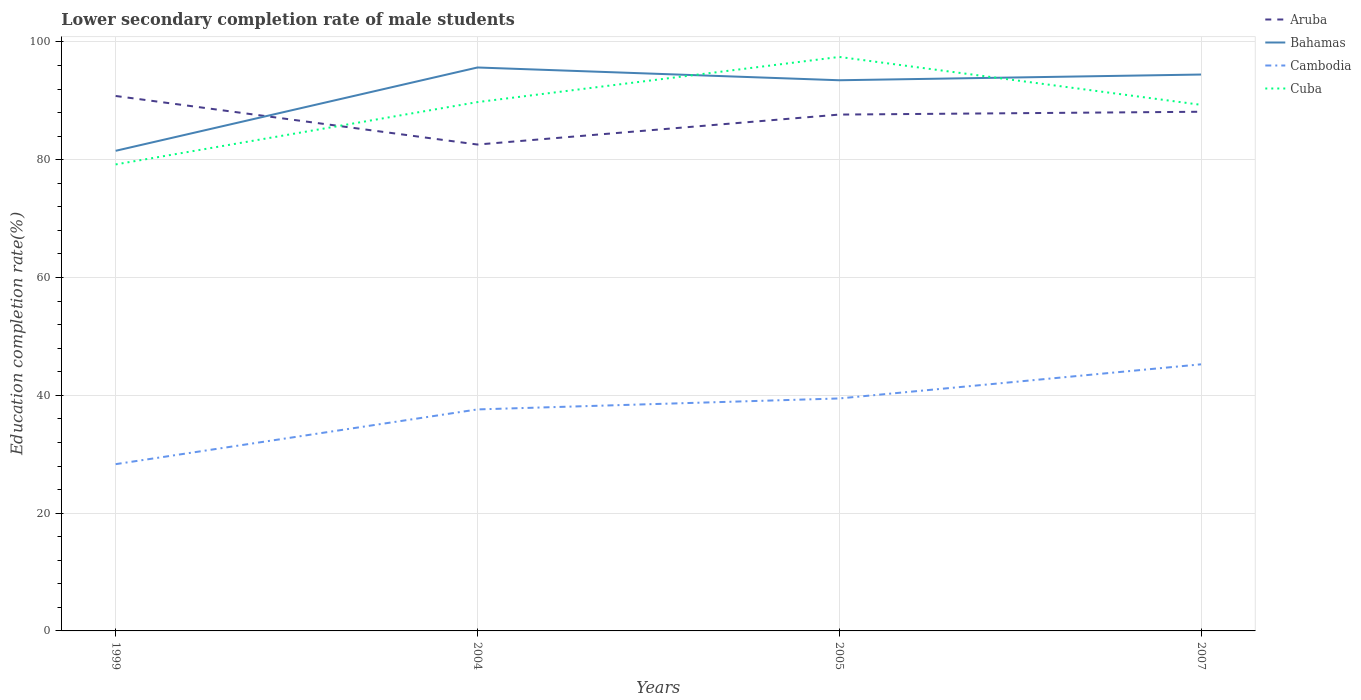How many different coloured lines are there?
Your response must be concise. 4. Is the number of lines equal to the number of legend labels?
Make the answer very short. Yes. Across all years, what is the maximum lower secondary completion rate of male students in Bahamas?
Offer a terse response. 81.51. What is the total lower secondary completion rate of male students in Cambodia in the graph?
Your response must be concise. -16.95. What is the difference between the highest and the second highest lower secondary completion rate of male students in Bahamas?
Make the answer very short. 14.15. How many years are there in the graph?
Your response must be concise. 4. What is the difference between two consecutive major ticks on the Y-axis?
Provide a succinct answer. 20. Are the values on the major ticks of Y-axis written in scientific E-notation?
Offer a terse response. No. Does the graph contain grids?
Make the answer very short. Yes. Where does the legend appear in the graph?
Offer a very short reply. Top right. How many legend labels are there?
Your answer should be very brief. 4. How are the legend labels stacked?
Your answer should be very brief. Vertical. What is the title of the graph?
Provide a short and direct response. Lower secondary completion rate of male students. What is the label or title of the X-axis?
Provide a short and direct response. Years. What is the label or title of the Y-axis?
Keep it short and to the point. Education completion rate(%). What is the Education completion rate(%) of Aruba in 1999?
Keep it short and to the point. 90.82. What is the Education completion rate(%) in Bahamas in 1999?
Your response must be concise. 81.51. What is the Education completion rate(%) of Cambodia in 1999?
Keep it short and to the point. 28.31. What is the Education completion rate(%) in Cuba in 1999?
Ensure brevity in your answer.  79.2. What is the Education completion rate(%) in Aruba in 2004?
Your answer should be compact. 82.58. What is the Education completion rate(%) in Bahamas in 2004?
Your answer should be compact. 95.66. What is the Education completion rate(%) in Cambodia in 2004?
Ensure brevity in your answer.  37.61. What is the Education completion rate(%) of Cuba in 2004?
Provide a succinct answer. 89.79. What is the Education completion rate(%) of Aruba in 2005?
Give a very brief answer. 87.67. What is the Education completion rate(%) of Bahamas in 2005?
Provide a short and direct response. 93.5. What is the Education completion rate(%) in Cambodia in 2005?
Offer a terse response. 39.47. What is the Education completion rate(%) of Cuba in 2005?
Ensure brevity in your answer.  97.45. What is the Education completion rate(%) in Aruba in 2007?
Your answer should be very brief. 88.15. What is the Education completion rate(%) in Bahamas in 2007?
Your answer should be very brief. 94.47. What is the Education completion rate(%) in Cambodia in 2007?
Offer a terse response. 45.26. What is the Education completion rate(%) of Cuba in 2007?
Your answer should be very brief. 89.32. Across all years, what is the maximum Education completion rate(%) in Aruba?
Your answer should be compact. 90.82. Across all years, what is the maximum Education completion rate(%) of Bahamas?
Give a very brief answer. 95.66. Across all years, what is the maximum Education completion rate(%) of Cambodia?
Your answer should be very brief. 45.26. Across all years, what is the maximum Education completion rate(%) in Cuba?
Your answer should be compact. 97.45. Across all years, what is the minimum Education completion rate(%) of Aruba?
Your response must be concise. 82.58. Across all years, what is the minimum Education completion rate(%) in Bahamas?
Your answer should be very brief. 81.51. Across all years, what is the minimum Education completion rate(%) in Cambodia?
Make the answer very short. 28.31. Across all years, what is the minimum Education completion rate(%) in Cuba?
Offer a terse response. 79.2. What is the total Education completion rate(%) in Aruba in the graph?
Provide a short and direct response. 349.22. What is the total Education completion rate(%) of Bahamas in the graph?
Your answer should be very brief. 365.14. What is the total Education completion rate(%) of Cambodia in the graph?
Ensure brevity in your answer.  150.65. What is the total Education completion rate(%) in Cuba in the graph?
Make the answer very short. 355.77. What is the difference between the Education completion rate(%) of Aruba in 1999 and that in 2004?
Your response must be concise. 8.25. What is the difference between the Education completion rate(%) of Bahamas in 1999 and that in 2004?
Your response must be concise. -14.15. What is the difference between the Education completion rate(%) in Cambodia in 1999 and that in 2004?
Give a very brief answer. -9.29. What is the difference between the Education completion rate(%) in Cuba in 1999 and that in 2004?
Your response must be concise. -10.58. What is the difference between the Education completion rate(%) of Aruba in 1999 and that in 2005?
Offer a very short reply. 3.16. What is the difference between the Education completion rate(%) in Bahamas in 1999 and that in 2005?
Provide a short and direct response. -11.98. What is the difference between the Education completion rate(%) of Cambodia in 1999 and that in 2005?
Your answer should be compact. -11.16. What is the difference between the Education completion rate(%) of Cuba in 1999 and that in 2005?
Your response must be concise. -18.25. What is the difference between the Education completion rate(%) in Aruba in 1999 and that in 2007?
Your response must be concise. 2.68. What is the difference between the Education completion rate(%) in Bahamas in 1999 and that in 2007?
Give a very brief answer. -12.95. What is the difference between the Education completion rate(%) of Cambodia in 1999 and that in 2007?
Ensure brevity in your answer.  -16.95. What is the difference between the Education completion rate(%) of Cuba in 1999 and that in 2007?
Your response must be concise. -10.12. What is the difference between the Education completion rate(%) of Aruba in 2004 and that in 2005?
Your answer should be very brief. -5.09. What is the difference between the Education completion rate(%) of Bahamas in 2004 and that in 2005?
Your answer should be very brief. 2.17. What is the difference between the Education completion rate(%) of Cambodia in 2004 and that in 2005?
Offer a terse response. -1.86. What is the difference between the Education completion rate(%) in Cuba in 2004 and that in 2005?
Provide a succinct answer. -7.67. What is the difference between the Education completion rate(%) in Aruba in 2004 and that in 2007?
Your response must be concise. -5.57. What is the difference between the Education completion rate(%) in Bahamas in 2004 and that in 2007?
Keep it short and to the point. 1.19. What is the difference between the Education completion rate(%) in Cambodia in 2004 and that in 2007?
Offer a terse response. -7.65. What is the difference between the Education completion rate(%) in Cuba in 2004 and that in 2007?
Provide a succinct answer. 0.46. What is the difference between the Education completion rate(%) of Aruba in 2005 and that in 2007?
Provide a short and direct response. -0.48. What is the difference between the Education completion rate(%) of Bahamas in 2005 and that in 2007?
Your response must be concise. -0.97. What is the difference between the Education completion rate(%) in Cambodia in 2005 and that in 2007?
Your answer should be compact. -5.79. What is the difference between the Education completion rate(%) in Cuba in 2005 and that in 2007?
Make the answer very short. 8.13. What is the difference between the Education completion rate(%) in Aruba in 1999 and the Education completion rate(%) in Bahamas in 2004?
Give a very brief answer. -4.84. What is the difference between the Education completion rate(%) of Aruba in 1999 and the Education completion rate(%) of Cambodia in 2004?
Offer a very short reply. 53.22. What is the difference between the Education completion rate(%) in Aruba in 1999 and the Education completion rate(%) in Cuba in 2004?
Offer a terse response. 1.04. What is the difference between the Education completion rate(%) of Bahamas in 1999 and the Education completion rate(%) of Cambodia in 2004?
Keep it short and to the point. 43.91. What is the difference between the Education completion rate(%) in Bahamas in 1999 and the Education completion rate(%) in Cuba in 2004?
Offer a terse response. -8.27. What is the difference between the Education completion rate(%) in Cambodia in 1999 and the Education completion rate(%) in Cuba in 2004?
Your answer should be compact. -61.47. What is the difference between the Education completion rate(%) in Aruba in 1999 and the Education completion rate(%) in Bahamas in 2005?
Your response must be concise. -2.67. What is the difference between the Education completion rate(%) in Aruba in 1999 and the Education completion rate(%) in Cambodia in 2005?
Make the answer very short. 51.35. What is the difference between the Education completion rate(%) of Aruba in 1999 and the Education completion rate(%) of Cuba in 2005?
Your answer should be compact. -6.63. What is the difference between the Education completion rate(%) in Bahamas in 1999 and the Education completion rate(%) in Cambodia in 2005?
Ensure brevity in your answer.  42.05. What is the difference between the Education completion rate(%) in Bahamas in 1999 and the Education completion rate(%) in Cuba in 2005?
Provide a succinct answer. -15.94. What is the difference between the Education completion rate(%) of Cambodia in 1999 and the Education completion rate(%) of Cuba in 2005?
Your answer should be compact. -69.14. What is the difference between the Education completion rate(%) of Aruba in 1999 and the Education completion rate(%) of Bahamas in 2007?
Your response must be concise. -3.64. What is the difference between the Education completion rate(%) of Aruba in 1999 and the Education completion rate(%) of Cambodia in 2007?
Ensure brevity in your answer.  45.56. What is the difference between the Education completion rate(%) of Aruba in 1999 and the Education completion rate(%) of Cuba in 2007?
Ensure brevity in your answer.  1.5. What is the difference between the Education completion rate(%) of Bahamas in 1999 and the Education completion rate(%) of Cambodia in 2007?
Your response must be concise. 36.25. What is the difference between the Education completion rate(%) in Bahamas in 1999 and the Education completion rate(%) in Cuba in 2007?
Provide a succinct answer. -7.81. What is the difference between the Education completion rate(%) in Cambodia in 1999 and the Education completion rate(%) in Cuba in 2007?
Your answer should be compact. -61.01. What is the difference between the Education completion rate(%) in Aruba in 2004 and the Education completion rate(%) in Bahamas in 2005?
Offer a very short reply. -10.92. What is the difference between the Education completion rate(%) in Aruba in 2004 and the Education completion rate(%) in Cambodia in 2005?
Provide a short and direct response. 43.11. What is the difference between the Education completion rate(%) of Aruba in 2004 and the Education completion rate(%) of Cuba in 2005?
Give a very brief answer. -14.87. What is the difference between the Education completion rate(%) of Bahamas in 2004 and the Education completion rate(%) of Cambodia in 2005?
Your answer should be very brief. 56.19. What is the difference between the Education completion rate(%) in Bahamas in 2004 and the Education completion rate(%) in Cuba in 2005?
Your response must be concise. -1.79. What is the difference between the Education completion rate(%) in Cambodia in 2004 and the Education completion rate(%) in Cuba in 2005?
Provide a short and direct response. -59.85. What is the difference between the Education completion rate(%) of Aruba in 2004 and the Education completion rate(%) of Bahamas in 2007?
Provide a short and direct response. -11.89. What is the difference between the Education completion rate(%) of Aruba in 2004 and the Education completion rate(%) of Cambodia in 2007?
Offer a terse response. 37.32. What is the difference between the Education completion rate(%) of Aruba in 2004 and the Education completion rate(%) of Cuba in 2007?
Offer a very short reply. -6.74. What is the difference between the Education completion rate(%) in Bahamas in 2004 and the Education completion rate(%) in Cambodia in 2007?
Your response must be concise. 50.4. What is the difference between the Education completion rate(%) of Bahamas in 2004 and the Education completion rate(%) of Cuba in 2007?
Your answer should be compact. 6.34. What is the difference between the Education completion rate(%) of Cambodia in 2004 and the Education completion rate(%) of Cuba in 2007?
Ensure brevity in your answer.  -51.72. What is the difference between the Education completion rate(%) in Aruba in 2005 and the Education completion rate(%) in Bahamas in 2007?
Your answer should be very brief. -6.8. What is the difference between the Education completion rate(%) in Aruba in 2005 and the Education completion rate(%) in Cambodia in 2007?
Provide a succinct answer. 42.4. What is the difference between the Education completion rate(%) in Aruba in 2005 and the Education completion rate(%) in Cuba in 2007?
Your response must be concise. -1.66. What is the difference between the Education completion rate(%) of Bahamas in 2005 and the Education completion rate(%) of Cambodia in 2007?
Your answer should be very brief. 48.23. What is the difference between the Education completion rate(%) in Bahamas in 2005 and the Education completion rate(%) in Cuba in 2007?
Provide a succinct answer. 4.17. What is the difference between the Education completion rate(%) in Cambodia in 2005 and the Education completion rate(%) in Cuba in 2007?
Make the answer very short. -49.85. What is the average Education completion rate(%) of Aruba per year?
Provide a succinct answer. 87.3. What is the average Education completion rate(%) of Bahamas per year?
Provide a short and direct response. 91.28. What is the average Education completion rate(%) of Cambodia per year?
Offer a very short reply. 37.66. What is the average Education completion rate(%) of Cuba per year?
Your answer should be compact. 88.94. In the year 1999, what is the difference between the Education completion rate(%) of Aruba and Education completion rate(%) of Bahamas?
Offer a very short reply. 9.31. In the year 1999, what is the difference between the Education completion rate(%) in Aruba and Education completion rate(%) in Cambodia?
Your response must be concise. 62.51. In the year 1999, what is the difference between the Education completion rate(%) of Aruba and Education completion rate(%) of Cuba?
Keep it short and to the point. 11.62. In the year 1999, what is the difference between the Education completion rate(%) of Bahamas and Education completion rate(%) of Cambodia?
Ensure brevity in your answer.  53.2. In the year 1999, what is the difference between the Education completion rate(%) of Bahamas and Education completion rate(%) of Cuba?
Offer a very short reply. 2.31. In the year 1999, what is the difference between the Education completion rate(%) in Cambodia and Education completion rate(%) in Cuba?
Your response must be concise. -50.89. In the year 2004, what is the difference between the Education completion rate(%) of Aruba and Education completion rate(%) of Bahamas?
Your answer should be very brief. -13.08. In the year 2004, what is the difference between the Education completion rate(%) in Aruba and Education completion rate(%) in Cambodia?
Provide a succinct answer. 44.97. In the year 2004, what is the difference between the Education completion rate(%) of Aruba and Education completion rate(%) of Cuba?
Your answer should be very brief. -7.21. In the year 2004, what is the difference between the Education completion rate(%) in Bahamas and Education completion rate(%) in Cambodia?
Give a very brief answer. 58.05. In the year 2004, what is the difference between the Education completion rate(%) in Bahamas and Education completion rate(%) in Cuba?
Provide a short and direct response. 5.87. In the year 2004, what is the difference between the Education completion rate(%) of Cambodia and Education completion rate(%) of Cuba?
Your response must be concise. -52.18. In the year 2005, what is the difference between the Education completion rate(%) of Aruba and Education completion rate(%) of Bahamas?
Your answer should be compact. -5.83. In the year 2005, what is the difference between the Education completion rate(%) in Aruba and Education completion rate(%) in Cambodia?
Make the answer very short. 48.2. In the year 2005, what is the difference between the Education completion rate(%) in Aruba and Education completion rate(%) in Cuba?
Your response must be concise. -9.79. In the year 2005, what is the difference between the Education completion rate(%) of Bahamas and Education completion rate(%) of Cambodia?
Provide a short and direct response. 54.03. In the year 2005, what is the difference between the Education completion rate(%) in Bahamas and Education completion rate(%) in Cuba?
Your response must be concise. -3.96. In the year 2005, what is the difference between the Education completion rate(%) in Cambodia and Education completion rate(%) in Cuba?
Give a very brief answer. -57.98. In the year 2007, what is the difference between the Education completion rate(%) in Aruba and Education completion rate(%) in Bahamas?
Keep it short and to the point. -6.32. In the year 2007, what is the difference between the Education completion rate(%) of Aruba and Education completion rate(%) of Cambodia?
Offer a very short reply. 42.88. In the year 2007, what is the difference between the Education completion rate(%) of Aruba and Education completion rate(%) of Cuba?
Ensure brevity in your answer.  -1.18. In the year 2007, what is the difference between the Education completion rate(%) of Bahamas and Education completion rate(%) of Cambodia?
Offer a very short reply. 49.2. In the year 2007, what is the difference between the Education completion rate(%) in Bahamas and Education completion rate(%) in Cuba?
Your response must be concise. 5.14. In the year 2007, what is the difference between the Education completion rate(%) of Cambodia and Education completion rate(%) of Cuba?
Provide a succinct answer. -44.06. What is the ratio of the Education completion rate(%) in Aruba in 1999 to that in 2004?
Give a very brief answer. 1.1. What is the ratio of the Education completion rate(%) in Bahamas in 1999 to that in 2004?
Give a very brief answer. 0.85. What is the ratio of the Education completion rate(%) of Cambodia in 1999 to that in 2004?
Ensure brevity in your answer.  0.75. What is the ratio of the Education completion rate(%) in Cuba in 1999 to that in 2004?
Your response must be concise. 0.88. What is the ratio of the Education completion rate(%) in Aruba in 1999 to that in 2005?
Offer a terse response. 1.04. What is the ratio of the Education completion rate(%) of Bahamas in 1999 to that in 2005?
Keep it short and to the point. 0.87. What is the ratio of the Education completion rate(%) of Cambodia in 1999 to that in 2005?
Your answer should be compact. 0.72. What is the ratio of the Education completion rate(%) in Cuba in 1999 to that in 2005?
Your answer should be very brief. 0.81. What is the ratio of the Education completion rate(%) of Aruba in 1999 to that in 2007?
Make the answer very short. 1.03. What is the ratio of the Education completion rate(%) in Bahamas in 1999 to that in 2007?
Keep it short and to the point. 0.86. What is the ratio of the Education completion rate(%) of Cambodia in 1999 to that in 2007?
Give a very brief answer. 0.63. What is the ratio of the Education completion rate(%) of Cuba in 1999 to that in 2007?
Provide a succinct answer. 0.89. What is the ratio of the Education completion rate(%) in Aruba in 2004 to that in 2005?
Your response must be concise. 0.94. What is the ratio of the Education completion rate(%) in Bahamas in 2004 to that in 2005?
Your answer should be very brief. 1.02. What is the ratio of the Education completion rate(%) in Cambodia in 2004 to that in 2005?
Offer a terse response. 0.95. What is the ratio of the Education completion rate(%) in Cuba in 2004 to that in 2005?
Keep it short and to the point. 0.92. What is the ratio of the Education completion rate(%) in Aruba in 2004 to that in 2007?
Keep it short and to the point. 0.94. What is the ratio of the Education completion rate(%) of Bahamas in 2004 to that in 2007?
Make the answer very short. 1.01. What is the ratio of the Education completion rate(%) of Cambodia in 2004 to that in 2007?
Offer a terse response. 0.83. What is the ratio of the Education completion rate(%) in Bahamas in 2005 to that in 2007?
Provide a short and direct response. 0.99. What is the ratio of the Education completion rate(%) in Cambodia in 2005 to that in 2007?
Offer a very short reply. 0.87. What is the ratio of the Education completion rate(%) in Cuba in 2005 to that in 2007?
Give a very brief answer. 1.09. What is the difference between the highest and the second highest Education completion rate(%) of Aruba?
Provide a succinct answer. 2.68. What is the difference between the highest and the second highest Education completion rate(%) in Bahamas?
Provide a short and direct response. 1.19. What is the difference between the highest and the second highest Education completion rate(%) of Cambodia?
Offer a terse response. 5.79. What is the difference between the highest and the second highest Education completion rate(%) of Cuba?
Offer a very short reply. 7.67. What is the difference between the highest and the lowest Education completion rate(%) of Aruba?
Offer a very short reply. 8.25. What is the difference between the highest and the lowest Education completion rate(%) in Bahamas?
Offer a terse response. 14.15. What is the difference between the highest and the lowest Education completion rate(%) in Cambodia?
Your answer should be very brief. 16.95. What is the difference between the highest and the lowest Education completion rate(%) of Cuba?
Make the answer very short. 18.25. 